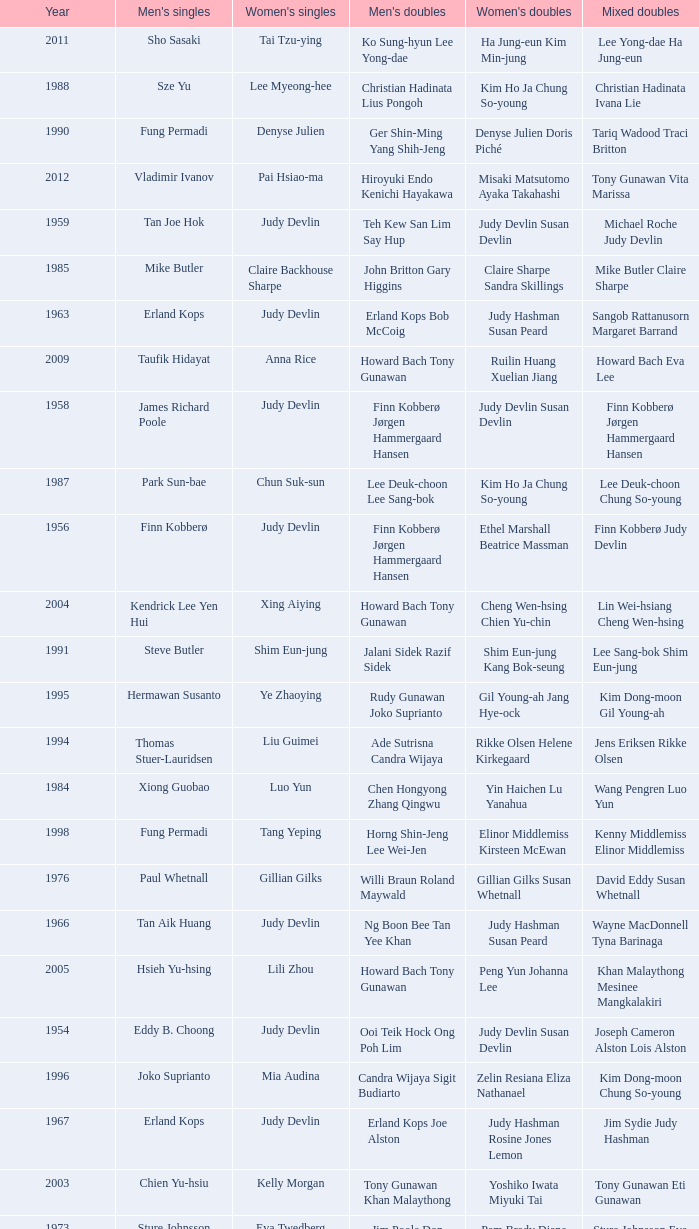Who were the men's doubles champions when the men's singles champion was muljadi? Ng Boon Bee Punch Gunalan. 